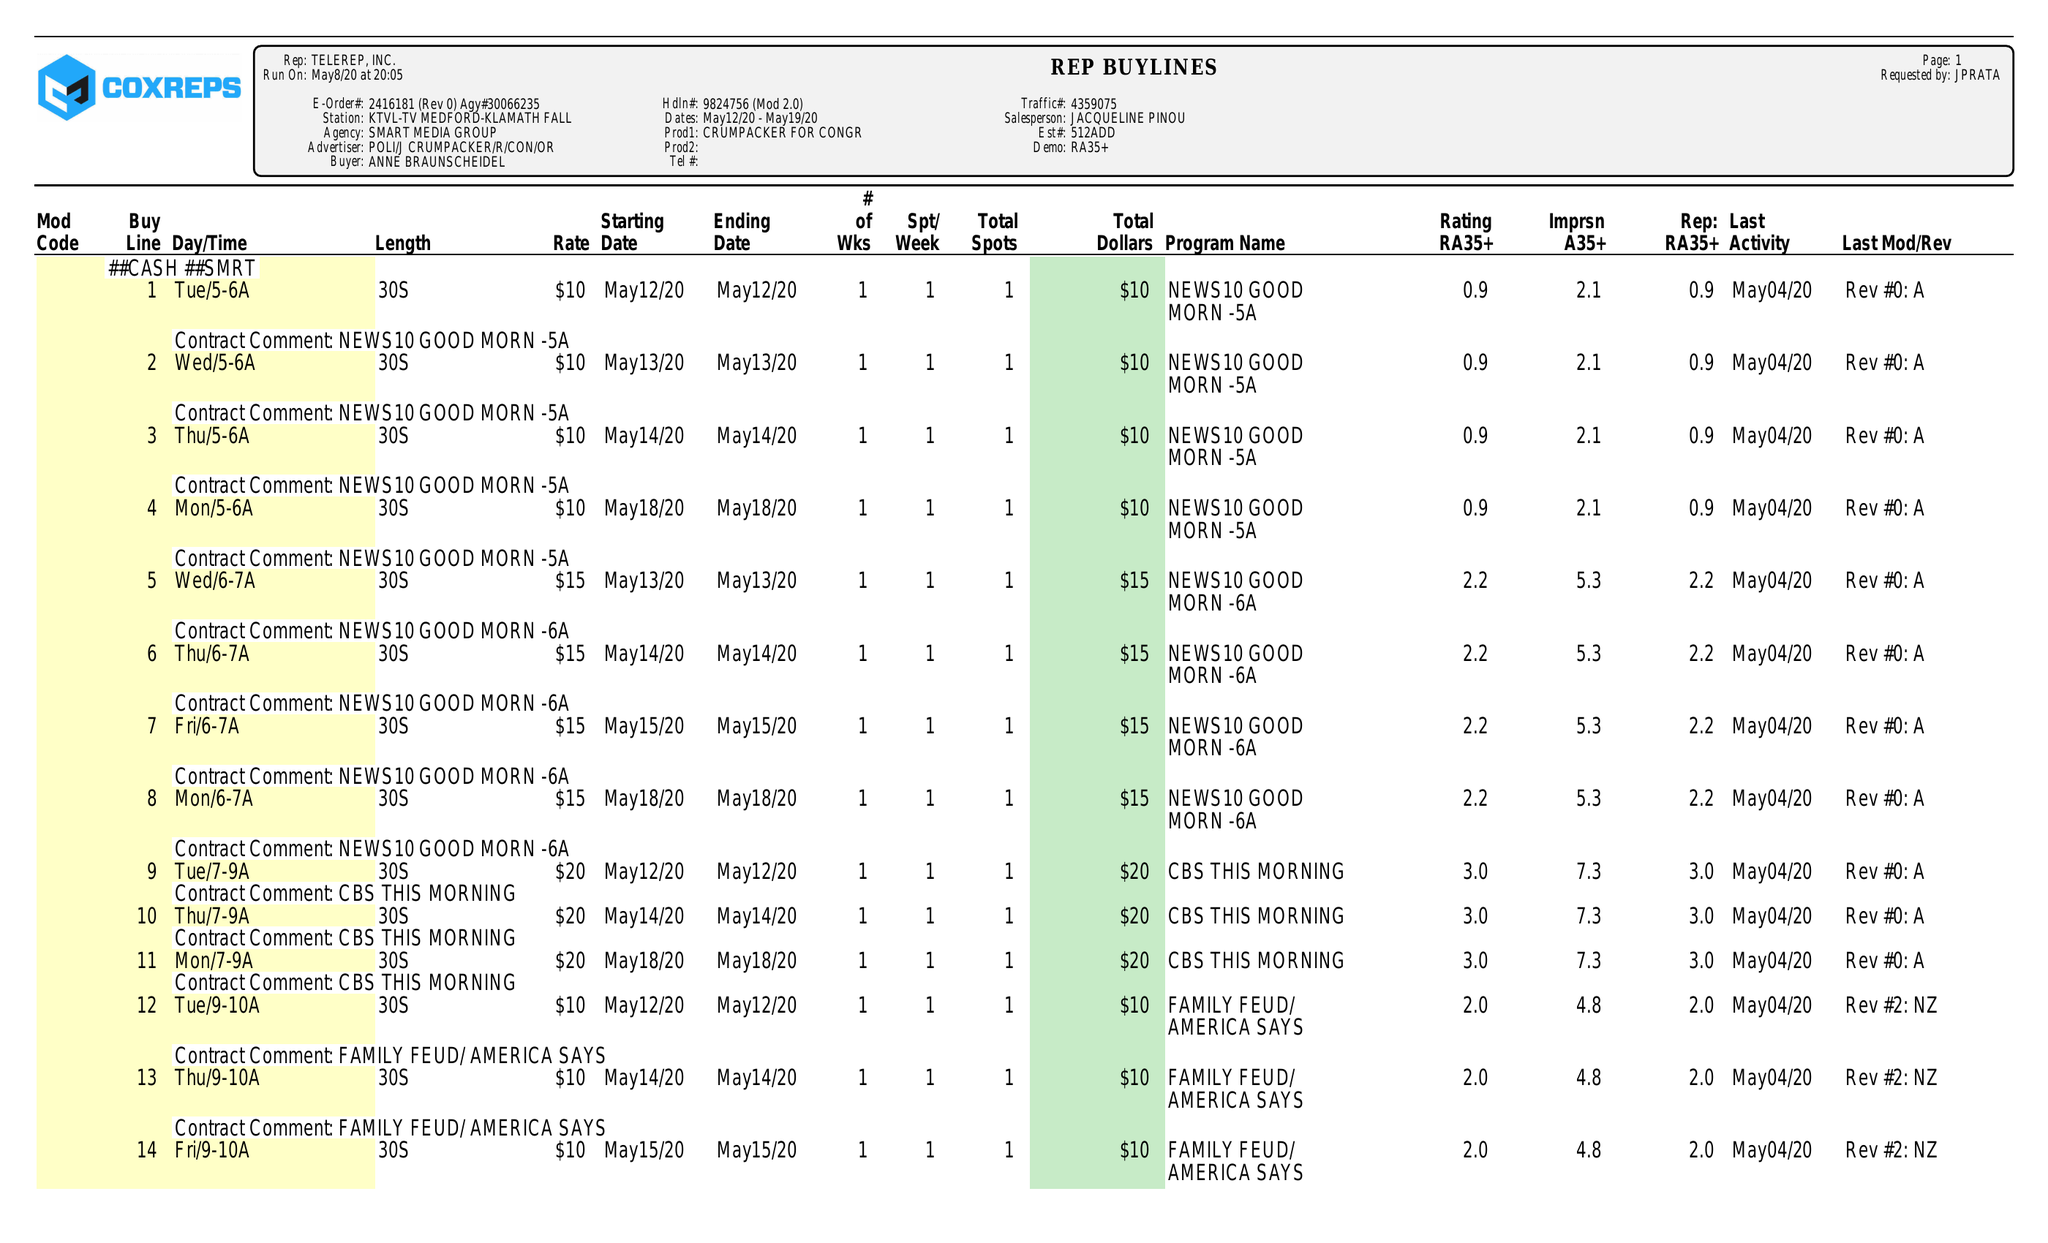What is the value for the contract_num?
Answer the question using a single word or phrase. 2416181 